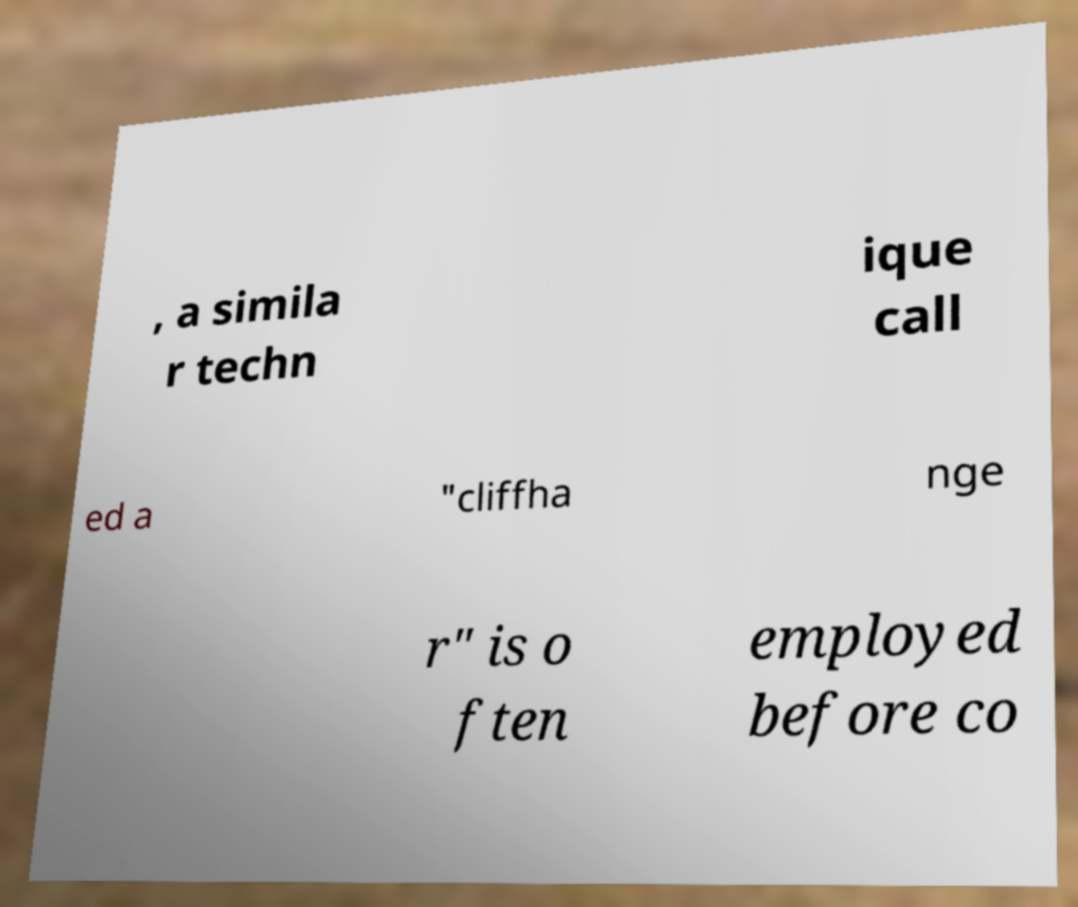For documentation purposes, I need the text within this image transcribed. Could you provide that? , a simila r techn ique call ed a "cliffha nge r" is o ften employed before co 